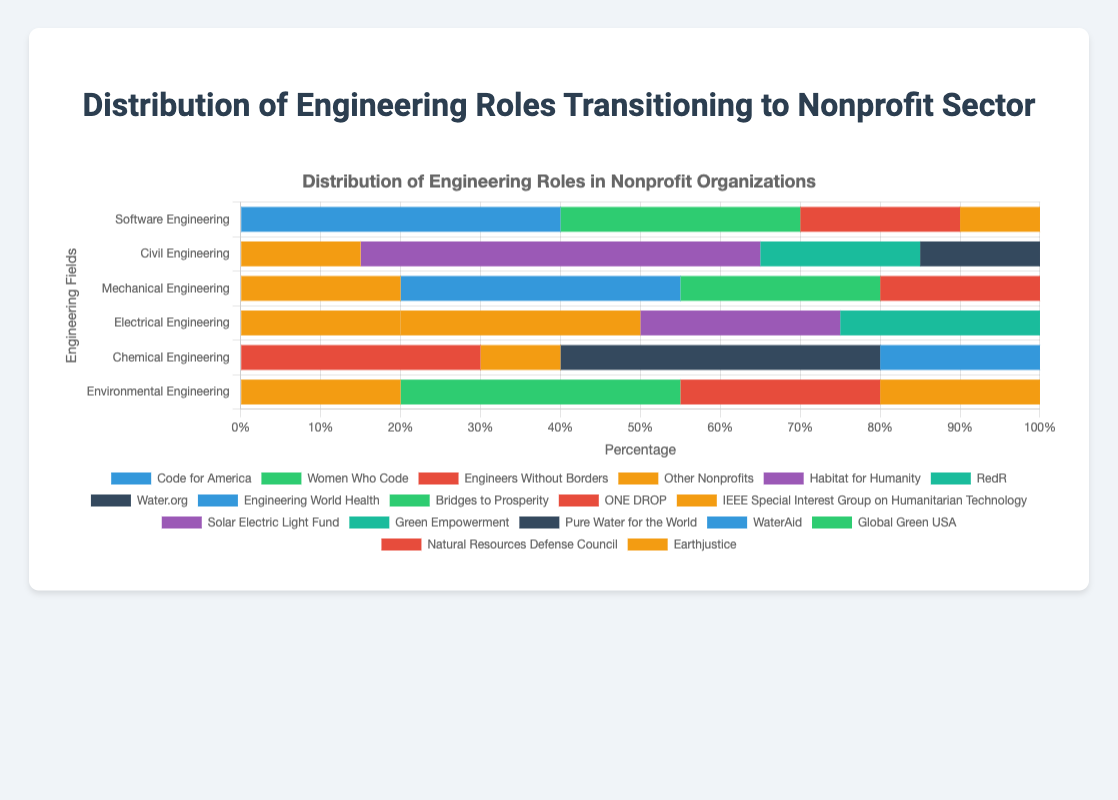Which field of engineering has the highest transition to Code for America? By looking at the section labeled "Code for America" in the horizontal stacked bars, Software Engineering clearly has the longest bar segment.
Answer: Software Engineering Which field of engineering has the smallest percentage transitioning to "Other Nonprofits"? Comparing the sections labeled "Other Nonprofits" across all six horizontal stacked bars, Software Engineering has the smallest segment.
Answer: Software Engineering How does the number of Software Engineers transitioning to Engineers Without Borders compare to Chemical Engineers transitioning to the same organization? The horizontal stacked bar for Software Engineering shows 20 for Engineers Without Borders, and the bar for Chemical Engineering shows 30. Thus, Chemical Engineers transitioning to Engineers Without Borders are higher by 10.
Answer: Chemical Engineers have 10 more What is the total percentage of Mechanical Engineers transitioning to ONE DROP and Bridges to Prosperity? The horizontal stacked bars show 20% for ONE DROP and 25% for Bridges to Prosperity for Mechanical Engineers. Summing these gives 45%.
Answer: 45% Which organization has the most substantial representation for Environmental Engineering? By scanning the horizontal stacked bars, "Global Green USA" has the longest segment within the Environmental Engineering bar, showing 35%.
Answer: Global Green USA Which organization within Electrical Engineering has the same number of transitioning engineers as "Green Empowerment"? Both the sections for "Solar Electric Light Fund" and "Green Empowerment" in the Electrical Engineering stacked bar show equal lengths, highlighting 25% each.
Answer: Solar Electric Light Fund Add the number of transitioning engineers from Civil Engineering at Habitat for Humanity and RedR. The bar segments for Habitat for Humanity and RedR in Civil Engineering show 50% and 20% respectively. Adding these two gives 70%.
Answer: 70% How does the number of engineers transitioning to Natural Resources Defense Council in Environmental Engineering compare to those transitioning to Engineers Without Borders in Chemical Engineering? Environmental Engineering's bar shows 25% for Natural Resources Defense Council, and Chemical Engineering's bar has 30% for Engineers Without Borders. Comparing these, Engineers Without Borders in Chemical Engineering exceeds by 5%.
Answer: Engineers Without Borders exceeds by 5% Which field of engineering has the longest segment for "Habitat for Humanity"? The horizontal stacked bar for Civil Engineering has a noticeable longest segment for "Habitat for Humanity" showing 50%.
Answer: Civil Engineering 